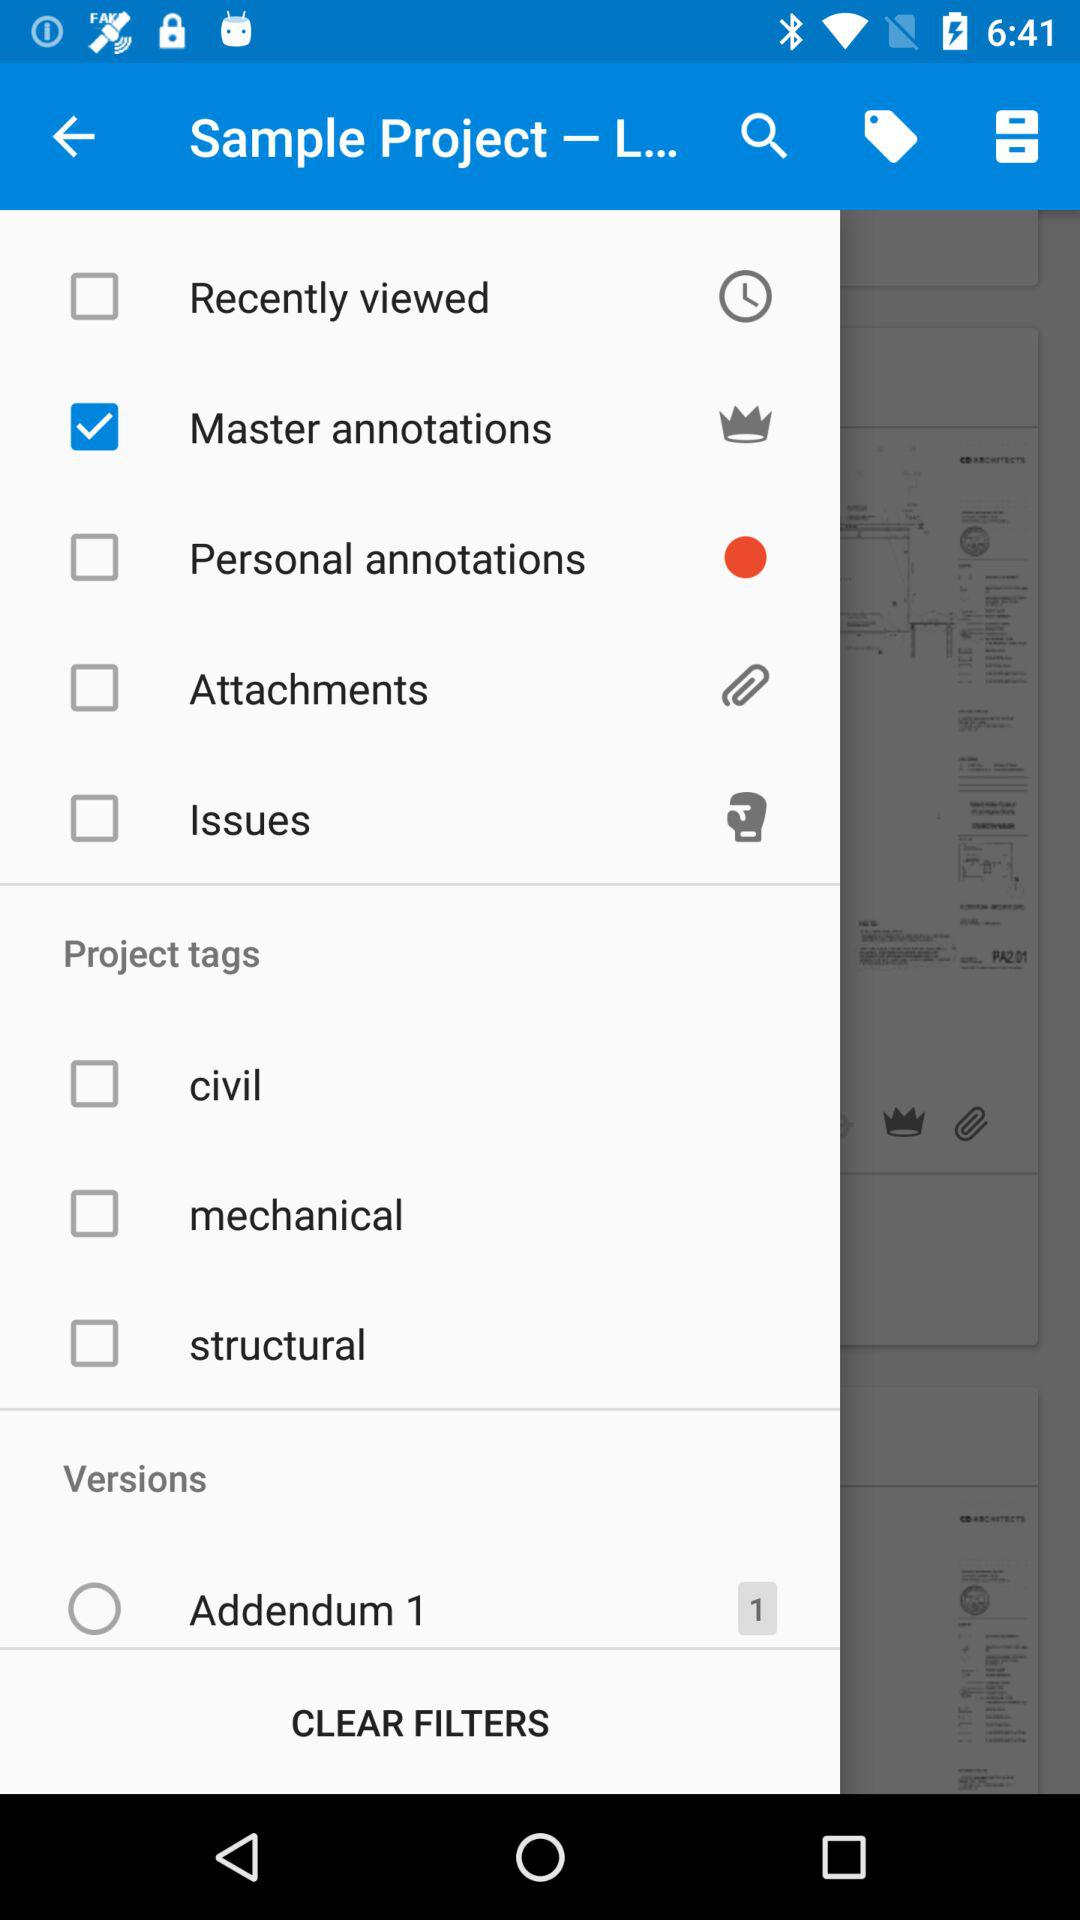What is the selected option? What is the selected item in the menu? The selected item in the menu is "Master annotations". 